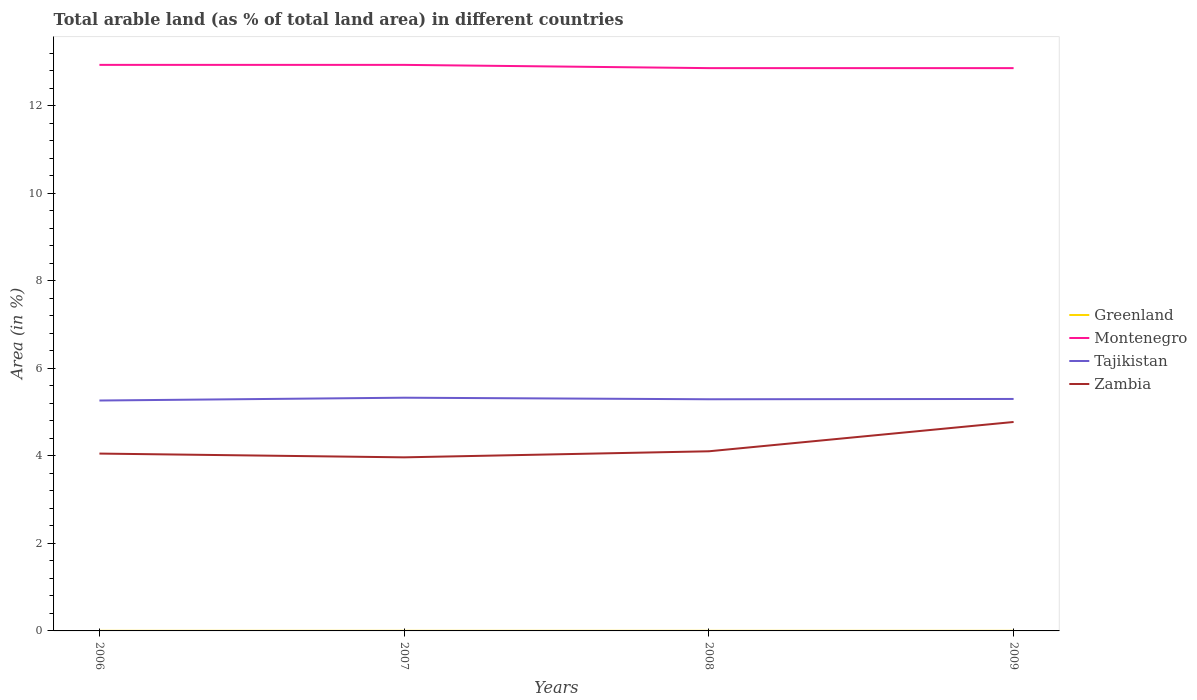Is the number of lines equal to the number of legend labels?
Offer a terse response. Yes. Across all years, what is the maximum percentage of arable land in Tajikistan?
Your answer should be very brief. 5.27. What is the difference between the highest and the lowest percentage of arable land in Tajikistan?
Offer a terse response. 2. How many lines are there?
Offer a very short reply. 4. What is the difference between two consecutive major ticks on the Y-axis?
Provide a succinct answer. 2. Are the values on the major ticks of Y-axis written in scientific E-notation?
Your answer should be compact. No. How are the legend labels stacked?
Make the answer very short. Vertical. What is the title of the graph?
Give a very brief answer. Total arable land (as % of total land area) in different countries. Does "Zambia" appear as one of the legend labels in the graph?
Your answer should be very brief. Yes. What is the label or title of the Y-axis?
Your answer should be compact. Area (in %). What is the Area (in %) of Greenland in 2006?
Give a very brief answer. 0. What is the Area (in %) of Montenegro in 2006?
Keep it short and to the point. 12.94. What is the Area (in %) of Tajikistan in 2006?
Your answer should be compact. 5.27. What is the Area (in %) of Zambia in 2006?
Give a very brief answer. 4.05. What is the Area (in %) of Greenland in 2007?
Your answer should be very brief. 0. What is the Area (in %) in Montenegro in 2007?
Make the answer very short. 12.94. What is the Area (in %) in Tajikistan in 2007?
Provide a succinct answer. 5.33. What is the Area (in %) in Zambia in 2007?
Provide a succinct answer. 3.97. What is the Area (in %) of Greenland in 2008?
Offer a terse response. 0. What is the Area (in %) in Montenegro in 2008?
Your response must be concise. 12.86. What is the Area (in %) of Tajikistan in 2008?
Provide a succinct answer. 5.29. What is the Area (in %) of Zambia in 2008?
Your answer should be compact. 4.11. What is the Area (in %) of Greenland in 2009?
Make the answer very short. 0. What is the Area (in %) in Montenegro in 2009?
Give a very brief answer. 12.86. What is the Area (in %) in Tajikistan in 2009?
Offer a terse response. 5.3. What is the Area (in %) in Zambia in 2009?
Provide a short and direct response. 4.78. Across all years, what is the maximum Area (in %) of Greenland?
Your response must be concise. 0. Across all years, what is the maximum Area (in %) in Montenegro?
Your answer should be compact. 12.94. Across all years, what is the maximum Area (in %) in Tajikistan?
Your answer should be very brief. 5.33. Across all years, what is the maximum Area (in %) in Zambia?
Provide a short and direct response. 4.78. Across all years, what is the minimum Area (in %) in Greenland?
Provide a succinct answer. 0. Across all years, what is the minimum Area (in %) of Montenegro?
Give a very brief answer. 12.86. Across all years, what is the minimum Area (in %) of Tajikistan?
Make the answer very short. 5.27. Across all years, what is the minimum Area (in %) in Zambia?
Provide a succinct answer. 3.97. What is the total Area (in %) in Greenland in the graph?
Your answer should be compact. 0.01. What is the total Area (in %) of Montenegro in the graph?
Your answer should be compact. 51.6. What is the total Area (in %) in Tajikistan in the graph?
Ensure brevity in your answer.  21.19. What is the total Area (in %) of Zambia in the graph?
Give a very brief answer. 16.9. What is the difference between the Area (in %) in Montenegro in 2006 and that in 2007?
Offer a terse response. 0. What is the difference between the Area (in %) of Tajikistan in 2006 and that in 2007?
Offer a terse response. -0.06. What is the difference between the Area (in %) of Zambia in 2006 and that in 2007?
Ensure brevity in your answer.  0.09. What is the difference between the Area (in %) of Montenegro in 2006 and that in 2008?
Your answer should be compact. 0.07. What is the difference between the Area (in %) in Tajikistan in 2006 and that in 2008?
Offer a very short reply. -0.03. What is the difference between the Area (in %) of Zambia in 2006 and that in 2008?
Offer a terse response. -0.05. What is the difference between the Area (in %) of Greenland in 2006 and that in 2009?
Offer a terse response. 0. What is the difference between the Area (in %) in Montenegro in 2006 and that in 2009?
Offer a very short reply. 0.07. What is the difference between the Area (in %) in Tajikistan in 2006 and that in 2009?
Provide a succinct answer. -0.04. What is the difference between the Area (in %) of Zambia in 2006 and that in 2009?
Provide a short and direct response. -0.72. What is the difference between the Area (in %) of Montenegro in 2007 and that in 2008?
Your answer should be very brief. 0.07. What is the difference between the Area (in %) of Tajikistan in 2007 and that in 2008?
Keep it short and to the point. 0.04. What is the difference between the Area (in %) of Zambia in 2007 and that in 2008?
Provide a succinct answer. -0.14. What is the difference between the Area (in %) in Greenland in 2007 and that in 2009?
Provide a short and direct response. 0. What is the difference between the Area (in %) of Montenegro in 2007 and that in 2009?
Your answer should be very brief. 0.07. What is the difference between the Area (in %) in Tajikistan in 2007 and that in 2009?
Provide a succinct answer. 0.03. What is the difference between the Area (in %) of Zambia in 2007 and that in 2009?
Your answer should be compact. -0.81. What is the difference between the Area (in %) in Montenegro in 2008 and that in 2009?
Make the answer very short. 0. What is the difference between the Area (in %) of Tajikistan in 2008 and that in 2009?
Offer a terse response. -0.01. What is the difference between the Area (in %) of Zambia in 2008 and that in 2009?
Offer a very short reply. -0.67. What is the difference between the Area (in %) of Greenland in 2006 and the Area (in %) of Montenegro in 2007?
Offer a terse response. -12.93. What is the difference between the Area (in %) of Greenland in 2006 and the Area (in %) of Tajikistan in 2007?
Ensure brevity in your answer.  -5.33. What is the difference between the Area (in %) of Greenland in 2006 and the Area (in %) of Zambia in 2007?
Give a very brief answer. -3.96. What is the difference between the Area (in %) of Montenegro in 2006 and the Area (in %) of Tajikistan in 2007?
Make the answer very short. 7.61. What is the difference between the Area (in %) of Montenegro in 2006 and the Area (in %) of Zambia in 2007?
Make the answer very short. 8.97. What is the difference between the Area (in %) of Tajikistan in 2006 and the Area (in %) of Zambia in 2007?
Give a very brief answer. 1.3. What is the difference between the Area (in %) of Greenland in 2006 and the Area (in %) of Montenegro in 2008?
Offer a terse response. -12.86. What is the difference between the Area (in %) of Greenland in 2006 and the Area (in %) of Tajikistan in 2008?
Provide a succinct answer. -5.29. What is the difference between the Area (in %) in Greenland in 2006 and the Area (in %) in Zambia in 2008?
Your answer should be compact. -4.1. What is the difference between the Area (in %) in Montenegro in 2006 and the Area (in %) in Tajikistan in 2008?
Offer a terse response. 7.64. What is the difference between the Area (in %) of Montenegro in 2006 and the Area (in %) of Zambia in 2008?
Offer a very short reply. 8.83. What is the difference between the Area (in %) in Tajikistan in 2006 and the Area (in %) in Zambia in 2008?
Offer a very short reply. 1.16. What is the difference between the Area (in %) of Greenland in 2006 and the Area (in %) of Montenegro in 2009?
Provide a succinct answer. -12.86. What is the difference between the Area (in %) of Greenland in 2006 and the Area (in %) of Tajikistan in 2009?
Give a very brief answer. -5.3. What is the difference between the Area (in %) of Greenland in 2006 and the Area (in %) of Zambia in 2009?
Offer a terse response. -4.77. What is the difference between the Area (in %) of Montenegro in 2006 and the Area (in %) of Tajikistan in 2009?
Provide a short and direct response. 7.64. What is the difference between the Area (in %) of Montenegro in 2006 and the Area (in %) of Zambia in 2009?
Provide a succinct answer. 8.16. What is the difference between the Area (in %) of Tajikistan in 2006 and the Area (in %) of Zambia in 2009?
Offer a very short reply. 0.49. What is the difference between the Area (in %) of Greenland in 2007 and the Area (in %) of Montenegro in 2008?
Make the answer very short. -12.86. What is the difference between the Area (in %) in Greenland in 2007 and the Area (in %) in Tajikistan in 2008?
Offer a terse response. -5.29. What is the difference between the Area (in %) in Greenland in 2007 and the Area (in %) in Zambia in 2008?
Your response must be concise. -4.1. What is the difference between the Area (in %) in Montenegro in 2007 and the Area (in %) in Tajikistan in 2008?
Your answer should be compact. 7.64. What is the difference between the Area (in %) in Montenegro in 2007 and the Area (in %) in Zambia in 2008?
Provide a succinct answer. 8.83. What is the difference between the Area (in %) of Tajikistan in 2007 and the Area (in %) of Zambia in 2008?
Keep it short and to the point. 1.22. What is the difference between the Area (in %) of Greenland in 2007 and the Area (in %) of Montenegro in 2009?
Provide a short and direct response. -12.86. What is the difference between the Area (in %) in Greenland in 2007 and the Area (in %) in Tajikistan in 2009?
Make the answer very short. -5.3. What is the difference between the Area (in %) in Greenland in 2007 and the Area (in %) in Zambia in 2009?
Offer a terse response. -4.77. What is the difference between the Area (in %) in Montenegro in 2007 and the Area (in %) in Tajikistan in 2009?
Your response must be concise. 7.64. What is the difference between the Area (in %) in Montenegro in 2007 and the Area (in %) in Zambia in 2009?
Provide a succinct answer. 8.16. What is the difference between the Area (in %) of Tajikistan in 2007 and the Area (in %) of Zambia in 2009?
Give a very brief answer. 0.55. What is the difference between the Area (in %) in Greenland in 2008 and the Area (in %) in Montenegro in 2009?
Your answer should be very brief. -12.86. What is the difference between the Area (in %) of Greenland in 2008 and the Area (in %) of Tajikistan in 2009?
Your answer should be very brief. -5.3. What is the difference between the Area (in %) of Greenland in 2008 and the Area (in %) of Zambia in 2009?
Make the answer very short. -4.77. What is the difference between the Area (in %) in Montenegro in 2008 and the Area (in %) in Tajikistan in 2009?
Offer a very short reply. 7.56. What is the difference between the Area (in %) in Montenegro in 2008 and the Area (in %) in Zambia in 2009?
Offer a terse response. 8.09. What is the difference between the Area (in %) in Tajikistan in 2008 and the Area (in %) in Zambia in 2009?
Your answer should be compact. 0.52. What is the average Area (in %) of Greenland per year?
Your answer should be very brief. 0. What is the average Area (in %) of Montenegro per year?
Provide a succinct answer. 12.9. What is the average Area (in %) of Tajikistan per year?
Ensure brevity in your answer.  5.3. What is the average Area (in %) of Zambia per year?
Keep it short and to the point. 4.23. In the year 2006, what is the difference between the Area (in %) in Greenland and Area (in %) in Montenegro?
Your response must be concise. -12.93. In the year 2006, what is the difference between the Area (in %) in Greenland and Area (in %) in Tajikistan?
Your answer should be compact. -5.26. In the year 2006, what is the difference between the Area (in %) in Greenland and Area (in %) in Zambia?
Offer a terse response. -4.05. In the year 2006, what is the difference between the Area (in %) in Montenegro and Area (in %) in Tajikistan?
Your answer should be compact. 7.67. In the year 2006, what is the difference between the Area (in %) of Montenegro and Area (in %) of Zambia?
Your response must be concise. 8.88. In the year 2006, what is the difference between the Area (in %) of Tajikistan and Area (in %) of Zambia?
Your answer should be very brief. 1.21. In the year 2007, what is the difference between the Area (in %) of Greenland and Area (in %) of Montenegro?
Your response must be concise. -12.93. In the year 2007, what is the difference between the Area (in %) of Greenland and Area (in %) of Tajikistan?
Keep it short and to the point. -5.33. In the year 2007, what is the difference between the Area (in %) of Greenland and Area (in %) of Zambia?
Your answer should be very brief. -3.96. In the year 2007, what is the difference between the Area (in %) in Montenegro and Area (in %) in Tajikistan?
Make the answer very short. 7.61. In the year 2007, what is the difference between the Area (in %) in Montenegro and Area (in %) in Zambia?
Your answer should be compact. 8.97. In the year 2007, what is the difference between the Area (in %) in Tajikistan and Area (in %) in Zambia?
Keep it short and to the point. 1.36. In the year 2008, what is the difference between the Area (in %) of Greenland and Area (in %) of Montenegro?
Your answer should be very brief. -12.86. In the year 2008, what is the difference between the Area (in %) in Greenland and Area (in %) in Tajikistan?
Provide a succinct answer. -5.29. In the year 2008, what is the difference between the Area (in %) of Greenland and Area (in %) of Zambia?
Provide a succinct answer. -4.1. In the year 2008, what is the difference between the Area (in %) in Montenegro and Area (in %) in Tajikistan?
Provide a short and direct response. 7.57. In the year 2008, what is the difference between the Area (in %) of Montenegro and Area (in %) of Zambia?
Your answer should be compact. 8.76. In the year 2008, what is the difference between the Area (in %) in Tajikistan and Area (in %) in Zambia?
Offer a terse response. 1.19. In the year 2009, what is the difference between the Area (in %) of Greenland and Area (in %) of Montenegro?
Offer a terse response. -12.86. In the year 2009, what is the difference between the Area (in %) of Greenland and Area (in %) of Tajikistan?
Provide a succinct answer. -5.3. In the year 2009, what is the difference between the Area (in %) in Greenland and Area (in %) in Zambia?
Your response must be concise. -4.77. In the year 2009, what is the difference between the Area (in %) of Montenegro and Area (in %) of Tajikistan?
Ensure brevity in your answer.  7.56. In the year 2009, what is the difference between the Area (in %) in Montenegro and Area (in %) in Zambia?
Provide a succinct answer. 8.09. In the year 2009, what is the difference between the Area (in %) in Tajikistan and Area (in %) in Zambia?
Your answer should be very brief. 0.53. What is the ratio of the Area (in %) of Greenland in 2006 to that in 2007?
Provide a short and direct response. 1. What is the ratio of the Area (in %) in Tajikistan in 2006 to that in 2007?
Provide a succinct answer. 0.99. What is the ratio of the Area (in %) in Zambia in 2006 to that in 2007?
Your response must be concise. 1.02. What is the ratio of the Area (in %) in Greenland in 2006 to that in 2008?
Your answer should be very brief. 1. What is the ratio of the Area (in %) of Zambia in 2006 to that in 2008?
Your answer should be compact. 0.99. What is the ratio of the Area (in %) in Greenland in 2006 to that in 2009?
Offer a very short reply. 1. What is the ratio of the Area (in %) of Tajikistan in 2006 to that in 2009?
Your answer should be compact. 0.99. What is the ratio of the Area (in %) of Zambia in 2006 to that in 2009?
Ensure brevity in your answer.  0.85. What is the ratio of the Area (in %) of Montenegro in 2007 to that in 2008?
Ensure brevity in your answer.  1.01. What is the ratio of the Area (in %) in Zambia in 2007 to that in 2008?
Provide a succinct answer. 0.97. What is the ratio of the Area (in %) of Tajikistan in 2007 to that in 2009?
Give a very brief answer. 1.01. What is the ratio of the Area (in %) of Zambia in 2007 to that in 2009?
Your answer should be compact. 0.83. What is the ratio of the Area (in %) of Greenland in 2008 to that in 2009?
Provide a succinct answer. 1. What is the ratio of the Area (in %) of Zambia in 2008 to that in 2009?
Provide a short and direct response. 0.86. What is the difference between the highest and the second highest Area (in %) in Tajikistan?
Your answer should be compact. 0.03. What is the difference between the highest and the second highest Area (in %) in Zambia?
Keep it short and to the point. 0.67. What is the difference between the highest and the lowest Area (in %) in Montenegro?
Your response must be concise. 0.07. What is the difference between the highest and the lowest Area (in %) of Tajikistan?
Give a very brief answer. 0.06. What is the difference between the highest and the lowest Area (in %) of Zambia?
Your answer should be very brief. 0.81. 